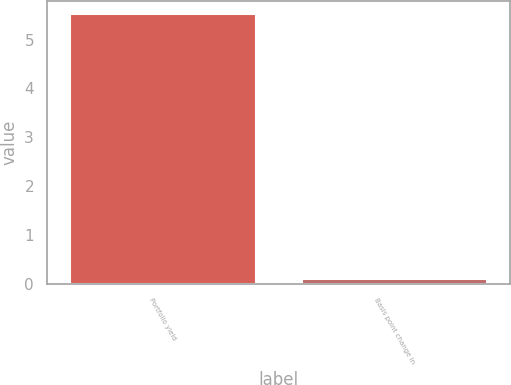<chart> <loc_0><loc_0><loc_500><loc_500><bar_chart><fcel>Portfolio yield<fcel>Basis point change in<nl><fcel>5.52<fcel>0.11<nl></chart> 